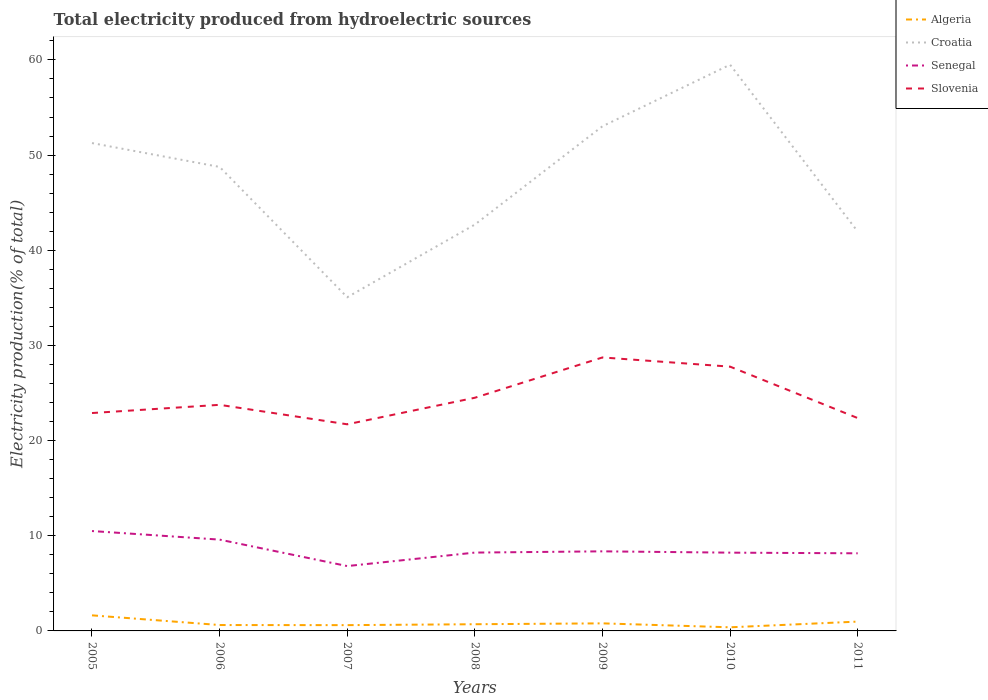Does the line corresponding to Senegal intersect with the line corresponding to Algeria?
Keep it short and to the point. No. Is the number of lines equal to the number of legend labels?
Your answer should be compact. Yes. Across all years, what is the maximum total electricity produced in Croatia?
Offer a very short reply. 35.06. What is the total total electricity produced in Algeria in the graph?
Offer a terse response. 1.02. What is the difference between the highest and the second highest total electricity produced in Slovenia?
Provide a short and direct response. 7.02. What is the difference between the highest and the lowest total electricity produced in Croatia?
Give a very brief answer. 4. Is the total electricity produced in Croatia strictly greater than the total electricity produced in Senegal over the years?
Keep it short and to the point. No. How many lines are there?
Keep it short and to the point. 4. How many years are there in the graph?
Offer a very short reply. 7. Where does the legend appear in the graph?
Provide a succinct answer. Top right. How many legend labels are there?
Make the answer very short. 4. How are the legend labels stacked?
Provide a short and direct response. Vertical. What is the title of the graph?
Give a very brief answer. Total electricity produced from hydroelectric sources. What is the label or title of the X-axis?
Your answer should be compact. Years. What is the Electricity production(% of total) of Algeria in 2005?
Provide a short and direct response. 1.64. What is the Electricity production(% of total) in Croatia in 2005?
Ensure brevity in your answer.  51.26. What is the Electricity production(% of total) in Senegal in 2005?
Give a very brief answer. 10.5. What is the Electricity production(% of total) of Slovenia in 2005?
Offer a terse response. 22.89. What is the Electricity production(% of total) in Algeria in 2006?
Your answer should be compact. 0.62. What is the Electricity production(% of total) of Croatia in 2006?
Your answer should be very brief. 48.76. What is the Electricity production(% of total) of Senegal in 2006?
Ensure brevity in your answer.  9.59. What is the Electricity production(% of total) of Slovenia in 2006?
Make the answer very short. 23.76. What is the Electricity production(% of total) in Algeria in 2007?
Your response must be concise. 0.61. What is the Electricity production(% of total) in Croatia in 2007?
Your answer should be compact. 35.06. What is the Electricity production(% of total) of Senegal in 2007?
Your answer should be compact. 6.81. What is the Electricity production(% of total) of Slovenia in 2007?
Keep it short and to the point. 21.71. What is the Electricity production(% of total) in Algeria in 2008?
Keep it short and to the point. 0.7. What is the Electricity production(% of total) of Croatia in 2008?
Your answer should be very brief. 42.7. What is the Electricity production(% of total) of Senegal in 2008?
Make the answer very short. 8.23. What is the Electricity production(% of total) in Slovenia in 2008?
Provide a short and direct response. 24.5. What is the Electricity production(% of total) of Algeria in 2009?
Ensure brevity in your answer.  0.79. What is the Electricity production(% of total) of Croatia in 2009?
Provide a short and direct response. 53.03. What is the Electricity production(% of total) of Senegal in 2009?
Give a very brief answer. 8.36. What is the Electricity production(% of total) in Slovenia in 2009?
Provide a short and direct response. 28.74. What is the Electricity production(% of total) in Algeria in 2010?
Make the answer very short. 0.38. What is the Electricity production(% of total) of Croatia in 2010?
Offer a terse response. 59.5. What is the Electricity production(% of total) in Senegal in 2010?
Offer a very short reply. 8.22. What is the Electricity production(% of total) of Slovenia in 2010?
Ensure brevity in your answer.  27.77. What is the Electricity production(% of total) of Algeria in 2011?
Provide a short and direct response. 0.98. What is the Electricity production(% of total) in Croatia in 2011?
Provide a succinct answer. 41.96. What is the Electricity production(% of total) in Senegal in 2011?
Your response must be concise. 8.16. What is the Electricity production(% of total) in Slovenia in 2011?
Provide a succinct answer. 22.37. Across all years, what is the maximum Electricity production(% of total) of Algeria?
Provide a short and direct response. 1.64. Across all years, what is the maximum Electricity production(% of total) in Croatia?
Your answer should be compact. 59.5. Across all years, what is the maximum Electricity production(% of total) in Senegal?
Give a very brief answer. 10.5. Across all years, what is the maximum Electricity production(% of total) of Slovenia?
Ensure brevity in your answer.  28.74. Across all years, what is the minimum Electricity production(% of total) in Algeria?
Make the answer very short. 0.38. Across all years, what is the minimum Electricity production(% of total) in Croatia?
Provide a short and direct response. 35.06. Across all years, what is the minimum Electricity production(% of total) of Senegal?
Keep it short and to the point. 6.81. Across all years, what is the minimum Electricity production(% of total) of Slovenia?
Ensure brevity in your answer.  21.71. What is the total Electricity production(% of total) of Algeria in the graph?
Ensure brevity in your answer.  5.72. What is the total Electricity production(% of total) in Croatia in the graph?
Give a very brief answer. 332.27. What is the total Electricity production(% of total) in Senegal in the graph?
Your answer should be very brief. 59.88. What is the total Electricity production(% of total) in Slovenia in the graph?
Your answer should be compact. 171.74. What is the difference between the Electricity production(% of total) in Algeria in 2005 and that in 2006?
Ensure brevity in your answer.  1.02. What is the difference between the Electricity production(% of total) in Croatia in 2005 and that in 2006?
Make the answer very short. 2.51. What is the difference between the Electricity production(% of total) of Senegal in 2005 and that in 2006?
Make the answer very short. 0.9. What is the difference between the Electricity production(% of total) of Slovenia in 2005 and that in 2006?
Provide a short and direct response. -0.86. What is the difference between the Electricity production(% of total) of Algeria in 2005 and that in 2007?
Give a very brief answer. 1.03. What is the difference between the Electricity production(% of total) of Croatia in 2005 and that in 2007?
Your answer should be compact. 16.2. What is the difference between the Electricity production(% of total) in Senegal in 2005 and that in 2007?
Keep it short and to the point. 3.68. What is the difference between the Electricity production(% of total) in Slovenia in 2005 and that in 2007?
Your answer should be very brief. 1.18. What is the difference between the Electricity production(% of total) in Algeria in 2005 and that in 2008?
Ensure brevity in your answer.  0.93. What is the difference between the Electricity production(% of total) of Croatia in 2005 and that in 2008?
Your answer should be compact. 8.56. What is the difference between the Electricity production(% of total) of Senegal in 2005 and that in 2008?
Your answer should be very brief. 2.26. What is the difference between the Electricity production(% of total) of Slovenia in 2005 and that in 2008?
Your answer should be compact. -1.61. What is the difference between the Electricity production(% of total) in Algeria in 2005 and that in 2009?
Provide a succinct answer. 0.84. What is the difference between the Electricity production(% of total) in Croatia in 2005 and that in 2009?
Give a very brief answer. -1.77. What is the difference between the Electricity production(% of total) of Senegal in 2005 and that in 2009?
Provide a short and direct response. 2.13. What is the difference between the Electricity production(% of total) in Slovenia in 2005 and that in 2009?
Keep it short and to the point. -5.84. What is the difference between the Electricity production(% of total) of Algeria in 2005 and that in 2010?
Make the answer very short. 1.26. What is the difference between the Electricity production(% of total) in Croatia in 2005 and that in 2010?
Your answer should be very brief. -8.23. What is the difference between the Electricity production(% of total) of Senegal in 2005 and that in 2010?
Offer a terse response. 2.27. What is the difference between the Electricity production(% of total) of Slovenia in 2005 and that in 2010?
Your answer should be compact. -4.87. What is the difference between the Electricity production(% of total) in Algeria in 2005 and that in 2011?
Offer a terse response. 0.66. What is the difference between the Electricity production(% of total) of Croatia in 2005 and that in 2011?
Offer a very short reply. 9.3. What is the difference between the Electricity production(% of total) in Senegal in 2005 and that in 2011?
Keep it short and to the point. 2.34. What is the difference between the Electricity production(% of total) in Slovenia in 2005 and that in 2011?
Provide a succinct answer. 0.53. What is the difference between the Electricity production(% of total) in Algeria in 2006 and that in 2007?
Provide a succinct answer. 0.01. What is the difference between the Electricity production(% of total) in Croatia in 2006 and that in 2007?
Ensure brevity in your answer.  13.69. What is the difference between the Electricity production(% of total) in Senegal in 2006 and that in 2007?
Offer a very short reply. 2.78. What is the difference between the Electricity production(% of total) in Slovenia in 2006 and that in 2007?
Offer a very short reply. 2.05. What is the difference between the Electricity production(% of total) of Algeria in 2006 and that in 2008?
Offer a very short reply. -0.08. What is the difference between the Electricity production(% of total) in Croatia in 2006 and that in 2008?
Offer a very short reply. 6.06. What is the difference between the Electricity production(% of total) in Senegal in 2006 and that in 2008?
Keep it short and to the point. 1.36. What is the difference between the Electricity production(% of total) in Slovenia in 2006 and that in 2008?
Your answer should be very brief. -0.74. What is the difference between the Electricity production(% of total) of Algeria in 2006 and that in 2009?
Make the answer very short. -0.18. What is the difference between the Electricity production(% of total) in Croatia in 2006 and that in 2009?
Provide a succinct answer. -4.27. What is the difference between the Electricity production(% of total) of Senegal in 2006 and that in 2009?
Your answer should be compact. 1.23. What is the difference between the Electricity production(% of total) in Slovenia in 2006 and that in 2009?
Provide a short and direct response. -4.98. What is the difference between the Electricity production(% of total) in Algeria in 2006 and that in 2010?
Your answer should be compact. 0.24. What is the difference between the Electricity production(% of total) of Croatia in 2006 and that in 2010?
Keep it short and to the point. -10.74. What is the difference between the Electricity production(% of total) in Senegal in 2006 and that in 2010?
Offer a very short reply. 1.37. What is the difference between the Electricity production(% of total) of Slovenia in 2006 and that in 2010?
Offer a terse response. -4.01. What is the difference between the Electricity production(% of total) in Algeria in 2006 and that in 2011?
Offer a very short reply. -0.36. What is the difference between the Electricity production(% of total) of Croatia in 2006 and that in 2011?
Offer a terse response. 6.79. What is the difference between the Electricity production(% of total) in Senegal in 2006 and that in 2011?
Give a very brief answer. 1.44. What is the difference between the Electricity production(% of total) in Slovenia in 2006 and that in 2011?
Your answer should be very brief. 1.39. What is the difference between the Electricity production(% of total) in Algeria in 2007 and that in 2008?
Give a very brief answer. -0.1. What is the difference between the Electricity production(% of total) in Croatia in 2007 and that in 2008?
Ensure brevity in your answer.  -7.63. What is the difference between the Electricity production(% of total) of Senegal in 2007 and that in 2008?
Your answer should be compact. -1.42. What is the difference between the Electricity production(% of total) of Slovenia in 2007 and that in 2008?
Make the answer very short. -2.79. What is the difference between the Electricity production(% of total) of Algeria in 2007 and that in 2009?
Give a very brief answer. -0.19. What is the difference between the Electricity production(% of total) in Croatia in 2007 and that in 2009?
Provide a succinct answer. -17.97. What is the difference between the Electricity production(% of total) of Senegal in 2007 and that in 2009?
Ensure brevity in your answer.  -1.55. What is the difference between the Electricity production(% of total) of Slovenia in 2007 and that in 2009?
Provide a short and direct response. -7.03. What is the difference between the Electricity production(% of total) of Algeria in 2007 and that in 2010?
Offer a very short reply. 0.23. What is the difference between the Electricity production(% of total) of Croatia in 2007 and that in 2010?
Provide a succinct answer. -24.43. What is the difference between the Electricity production(% of total) of Senegal in 2007 and that in 2010?
Your answer should be very brief. -1.41. What is the difference between the Electricity production(% of total) in Slovenia in 2007 and that in 2010?
Your answer should be very brief. -6.06. What is the difference between the Electricity production(% of total) in Algeria in 2007 and that in 2011?
Provide a short and direct response. -0.37. What is the difference between the Electricity production(% of total) in Croatia in 2007 and that in 2011?
Provide a short and direct response. -6.9. What is the difference between the Electricity production(% of total) in Senegal in 2007 and that in 2011?
Provide a succinct answer. -1.34. What is the difference between the Electricity production(% of total) in Slovenia in 2007 and that in 2011?
Offer a very short reply. -0.65. What is the difference between the Electricity production(% of total) in Algeria in 2008 and that in 2009?
Ensure brevity in your answer.  -0.09. What is the difference between the Electricity production(% of total) in Croatia in 2008 and that in 2009?
Ensure brevity in your answer.  -10.33. What is the difference between the Electricity production(% of total) of Senegal in 2008 and that in 2009?
Offer a very short reply. -0.13. What is the difference between the Electricity production(% of total) in Slovenia in 2008 and that in 2009?
Make the answer very short. -4.23. What is the difference between the Electricity production(% of total) in Algeria in 2008 and that in 2010?
Your answer should be compact. 0.32. What is the difference between the Electricity production(% of total) of Croatia in 2008 and that in 2010?
Ensure brevity in your answer.  -16.8. What is the difference between the Electricity production(% of total) in Senegal in 2008 and that in 2010?
Your response must be concise. 0.01. What is the difference between the Electricity production(% of total) of Slovenia in 2008 and that in 2010?
Your response must be concise. -3.27. What is the difference between the Electricity production(% of total) of Algeria in 2008 and that in 2011?
Make the answer very short. -0.28. What is the difference between the Electricity production(% of total) of Croatia in 2008 and that in 2011?
Provide a succinct answer. 0.73. What is the difference between the Electricity production(% of total) of Senegal in 2008 and that in 2011?
Make the answer very short. 0.08. What is the difference between the Electricity production(% of total) of Slovenia in 2008 and that in 2011?
Your answer should be compact. 2.14. What is the difference between the Electricity production(% of total) of Algeria in 2009 and that in 2010?
Your response must be concise. 0.41. What is the difference between the Electricity production(% of total) of Croatia in 2009 and that in 2010?
Offer a very short reply. -6.47. What is the difference between the Electricity production(% of total) in Senegal in 2009 and that in 2010?
Your answer should be compact. 0.14. What is the difference between the Electricity production(% of total) of Slovenia in 2009 and that in 2010?
Provide a succinct answer. 0.97. What is the difference between the Electricity production(% of total) of Algeria in 2009 and that in 2011?
Your answer should be very brief. -0.19. What is the difference between the Electricity production(% of total) of Croatia in 2009 and that in 2011?
Give a very brief answer. 11.07. What is the difference between the Electricity production(% of total) in Senegal in 2009 and that in 2011?
Provide a succinct answer. 0.21. What is the difference between the Electricity production(% of total) of Slovenia in 2009 and that in 2011?
Ensure brevity in your answer.  6.37. What is the difference between the Electricity production(% of total) in Algeria in 2010 and that in 2011?
Provide a short and direct response. -0.6. What is the difference between the Electricity production(% of total) in Croatia in 2010 and that in 2011?
Give a very brief answer. 17.53. What is the difference between the Electricity production(% of total) in Senegal in 2010 and that in 2011?
Your answer should be compact. 0.07. What is the difference between the Electricity production(% of total) of Slovenia in 2010 and that in 2011?
Ensure brevity in your answer.  5.4. What is the difference between the Electricity production(% of total) in Algeria in 2005 and the Electricity production(% of total) in Croatia in 2006?
Make the answer very short. -47.12. What is the difference between the Electricity production(% of total) in Algeria in 2005 and the Electricity production(% of total) in Senegal in 2006?
Your answer should be compact. -7.96. What is the difference between the Electricity production(% of total) in Algeria in 2005 and the Electricity production(% of total) in Slovenia in 2006?
Offer a very short reply. -22.12. What is the difference between the Electricity production(% of total) of Croatia in 2005 and the Electricity production(% of total) of Senegal in 2006?
Give a very brief answer. 41.67. What is the difference between the Electricity production(% of total) of Croatia in 2005 and the Electricity production(% of total) of Slovenia in 2006?
Offer a terse response. 27.5. What is the difference between the Electricity production(% of total) in Senegal in 2005 and the Electricity production(% of total) in Slovenia in 2006?
Give a very brief answer. -13.26. What is the difference between the Electricity production(% of total) of Algeria in 2005 and the Electricity production(% of total) of Croatia in 2007?
Offer a terse response. -33.43. What is the difference between the Electricity production(% of total) of Algeria in 2005 and the Electricity production(% of total) of Senegal in 2007?
Provide a short and direct response. -5.18. What is the difference between the Electricity production(% of total) of Algeria in 2005 and the Electricity production(% of total) of Slovenia in 2007?
Offer a very short reply. -20.07. What is the difference between the Electricity production(% of total) of Croatia in 2005 and the Electricity production(% of total) of Senegal in 2007?
Your answer should be very brief. 44.45. What is the difference between the Electricity production(% of total) in Croatia in 2005 and the Electricity production(% of total) in Slovenia in 2007?
Your answer should be compact. 29.55. What is the difference between the Electricity production(% of total) in Senegal in 2005 and the Electricity production(% of total) in Slovenia in 2007?
Offer a terse response. -11.22. What is the difference between the Electricity production(% of total) of Algeria in 2005 and the Electricity production(% of total) of Croatia in 2008?
Give a very brief answer. -41.06. What is the difference between the Electricity production(% of total) of Algeria in 2005 and the Electricity production(% of total) of Senegal in 2008?
Offer a terse response. -6.59. What is the difference between the Electricity production(% of total) in Algeria in 2005 and the Electricity production(% of total) in Slovenia in 2008?
Provide a short and direct response. -22.86. What is the difference between the Electricity production(% of total) in Croatia in 2005 and the Electricity production(% of total) in Senegal in 2008?
Keep it short and to the point. 43.03. What is the difference between the Electricity production(% of total) in Croatia in 2005 and the Electricity production(% of total) in Slovenia in 2008?
Give a very brief answer. 26.76. What is the difference between the Electricity production(% of total) of Senegal in 2005 and the Electricity production(% of total) of Slovenia in 2008?
Your answer should be compact. -14.01. What is the difference between the Electricity production(% of total) of Algeria in 2005 and the Electricity production(% of total) of Croatia in 2009?
Your response must be concise. -51.39. What is the difference between the Electricity production(% of total) of Algeria in 2005 and the Electricity production(% of total) of Senegal in 2009?
Offer a terse response. -6.73. What is the difference between the Electricity production(% of total) in Algeria in 2005 and the Electricity production(% of total) in Slovenia in 2009?
Offer a very short reply. -27.1. What is the difference between the Electricity production(% of total) of Croatia in 2005 and the Electricity production(% of total) of Senegal in 2009?
Your answer should be compact. 42.9. What is the difference between the Electricity production(% of total) of Croatia in 2005 and the Electricity production(% of total) of Slovenia in 2009?
Keep it short and to the point. 22.53. What is the difference between the Electricity production(% of total) in Senegal in 2005 and the Electricity production(% of total) in Slovenia in 2009?
Your answer should be compact. -18.24. What is the difference between the Electricity production(% of total) of Algeria in 2005 and the Electricity production(% of total) of Croatia in 2010?
Provide a short and direct response. -57.86. What is the difference between the Electricity production(% of total) of Algeria in 2005 and the Electricity production(% of total) of Senegal in 2010?
Your response must be concise. -6.59. What is the difference between the Electricity production(% of total) of Algeria in 2005 and the Electricity production(% of total) of Slovenia in 2010?
Your response must be concise. -26.13. What is the difference between the Electricity production(% of total) in Croatia in 2005 and the Electricity production(% of total) in Senegal in 2010?
Give a very brief answer. 43.04. What is the difference between the Electricity production(% of total) of Croatia in 2005 and the Electricity production(% of total) of Slovenia in 2010?
Provide a short and direct response. 23.49. What is the difference between the Electricity production(% of total) in Senegal in 2005 and the Electricity production(% of total) in Slovenia in 2010?
Ensure brevity in your answer.  -17.27. What is the difference between the Electricity production(% of total) of Algeria in 2005 and the Electricity production(% of total) of Croatia in 2011?
Your answer should be very brief. -40.33. What is the difference between the Electricity production(% of total) of Algeria in 2005 and the Electricity production(% of total) of Senegal in 2011?
Offer a terse response. -6.52. What is the difference between the Electricity production(% of total) in Algeria in 2005 and the Electricity production(% of total) in Slovenia in 2011?
Offer a terse response. -20.73. What is the difference between the Electricity production(% of total) in Croatia in 2005 and the Electricity production(% of total) in Senegal in 2011?
Your answer should be compact. 43.11. What is the difference between the Electricity production(% of total) in Croatia in 2005 and the Electricity production(% of total) in Slovenia in 2011?
Ensure brevity in your answer.  28.9. What is the difference between the Electricity production(% of total) of Senegal in 2005 and the Electricity production(% of total) of Slovenia in 2011?
Offer a terse response. -11.87. What is the difference between the Electricity production(% of total) in Algeria in 2006 and the Electricity production(% of total) in Croatia in 2007?
Offer a terse response. -34.44. What is the difference between the Electricity production(% of total) in Algeria in 2006 and the Electricity production(% of total) in Senegal in 2007?
Your answer should be very brief. -6.2. What is the difference between the Electricity production(% of total) in Algeria in 2006 and the Electricity production(% of total) in Slovenia in 2007?
Offer a very short reply. -21.09. What is the difference between the Electricity production(% of total) in Croatia in 2006 and the Electricity production(% of total) in Senegal in 2007?
Offer a very short reply. 41.94. What is the difference between the Electricity production(% of total) of Croatia in 2006 and the Electricity production(% of total) of Slovenia in 2007?
Provide a short and direct response. 27.05. What is the difference between the Electricity production(% of total) in Senegal in 2006 and the Electricity production(% of total) in Slovenia in 2007?
Provide a short and direct response. -12.12. What is the difference between the Electricity production(% of total) in Algeria in 2006 and the Electricity production(% of total) in Croatia in 2008?
Give a very brief answer. -42.08. What is the difference between the Electricity production(% of total) in Algeria in 2006 and the Electricity production(% of total) in Senegal in 2008?
Your response must be concise. -7.61. What is the difference between the Electricity production(% of total) in Algeria in 2006 and the Electricity production(% of total) in Slovenia in 2008?
Your response must be concise. -23.88. What is the difference between the Electricity production(% of total) of Croatia in 2006 and the Electricity production(% of total) of Senegal in 2008?
Keep it short and to the point. 40.53. What is the difference between the Electricity production(% of total) in Croatia in 2006 and the Electricity production(% of total) in Slovenia in 2008?
Make the answer very short. 24.26. What is the difference between the Electricity production(% of total) of Senegal in 2006 and the Electricity production(% of total) of Slovenia in 2008?
Offer a very short reply. -14.91. What is the difference between the Electricity production(% of total) in Algeria in 2006 and the Electricity production(% of total) in Croatia in 2009?
Provide a short and direct response. -52.41. What is the difference between the Electricity production(% of total) in Algeria in 2006 and the Electricity production(% of total) in Senegal in 2009?
Your answer should be very brief. -7.74. What is the difference between the Electricity production(% of total) of Algeria in 2006 and the Electricity production(% of total) of Slovenia in 2009?
Give a very brief answer. -28.12. What is the difference between the Electricity production(% of total) of Croatia in 2006 and the Electricity production(% of total) of Senegal in 2009?
Make the answer very short. 40.39. What is the difference between the Electricity production(% of total) of Croatia in 2006 and the Electricity production(% of total) of Slovenia in 2009?
Provide a succinct answer. 20.02. What is the difference between the Electricity production(% of total) in Senegal in 2006 and the Electricity production(% of total) in Slovenia in 2009?
Offer a very short reply. -19.14. What is the difference between the Electricity production(% of total) of Algeria in 2006 and the Electricity production(% of total) of Croatia in 2010?
Your answer should be very brief. -58.88. What is the difference between the Electricity production(% of total) in Algeria in 2006 and the Electricity production(% of total) in Senegal in 2010?
Ensure brevity in your answer.  -7.61. What is the difference between the Electricity production(% of total) of Algeria in 2006 and the Electricity production(% of total) of Slovenia in 2010?
Offer a very short reply. -27.15. What is the difference between the Electricity production(% of total) of Croatia in 2006 and the Electricity production(% of total) of Senegal in 2010?
Your answer should be very brief. 40.53. What is the difference between the Electricity production(% of total) of Croatia in 2006 and the Electricity production(% of total) of Slovenia in 2010?
Ensure brevity in your answer.  20.99. What is the difference between the Electricity production(% of total) in Senegal in 2006 and the Electricity production(% of total) in Slovenia in 2010?
Make the answer very short. -18.18. What is the difference between the Electricity production(% of total) of Algeria in 2006 and the Electricity production(% of total) of Croatia in 2011?
Your answer should be compact. -41.35. What is the difference between the Electricity production(% of total) of Algeria in 2006 and the Electricity production(% of total) of Senegal in 2011?
Make the answer very short. -7.54. What is the difference between the Electricity production(% of total) in Algeria in 2006 and the Electricity production(% of total) in Slovenia in 2011?
Keep it short and to the point. -21.75. What is the difference between the Electricity production(% of total) of Croatia in 2006 and the Electricity production(% of total) of Senegal in 2011?
Offer a terse response. 40.6. What is the difference between the Electricity production(% of total) of Croatia in 2006 and the Electricity production(% of total) of Slovenia in 2011?
Your answer should be very brief. 26.39. What is the difference between the Electricity production(% of total) of Senegal in 2006 and the Electricity production(% of total) of Slovenia in 2011?
Your response must be concise. -12.77. What is the difference between the Electricity production(% of total) in Algeria in 2007 and the Electricity production(% of total) in Croatia in 2008?
Provide a short and direct response. -42.09. What is the difference between the Electricity production(% of total) of Algeria in 2007 and the Electricity production(% of total) of Senegal in 2008?
Provide a short and direct response. -7.62. What is the difference between the Electricity production(% of total) in Algeria in 2007 and the Electricity production(% of total) in Slovenia in 2008?
Your answer should be very brief. -23.89. What is the difference between the Electricity production(% of total) in Croatia in 2007 and the Electricity production(% of total) in Senegal in 2008?
Offer a very short reply. 26.83. What is the difference between the Electricity production(% of total) of Croatia in 2007 and the Electricity production(% of total) of Slovenia in 2008?
Your answer should be compact. 10.56. What is the difference between the Electricity production(% of total) in Senegal in 2007 and the Electricity production(% of total) in Slovenia in 2008?
Make the answer very short. -17.69. What is the difference between the Electricity production(% of total) of Algeria in 2007 and the Electricity production(% of total) of Croatia in 2009?
Offer a very short reply. -52.42. What is the difference between the Electricity production(% of total) in Algeria in 2007 and the Electricity production(% of total) in Senegal in 2009?
Give a very brief answer. -7.75. What is the difference between the Electricity production(% of total) in Algeria in 2007 and the Electricity production(% of total) in Slovenia in 2009?
Ensure brevity in your answer.  -28.13. What is the difference between the Electricity production(% of total) of Croatia in 2007 and the Electricity production(% of total) of Senegal in 2009?
Keep it short and to the point. 26.7. What is the difference between the Electricity production(% of total) of Croatia in 2007 and the Electricity production(% of total) of Slovenia in 2009?
Provide a short and direct response. 6.33. What is the difference between the Electricity production(% of total) in Senegal in 2007 and the Electricity production(% of total) in Slovenia in 2009?
Offer a terse response. -21.92. What is the difference between the Electricity production(% of total) of Algeria in 2007 and the Electricity production(% of total) of Croatia in 2010?
Give a very brief answer. -58.89. What is the difference between the Electricity production(% of total) of Algeria in 2007 and the Electricity production(% of total) of Senegal in 2010?
Provide a succinct answer. -7.62. What is the difference between the Electricity production(% of total) in Algeria in 2007 and the Electricity production(% of total) in Slovenia in 2010?
Make the answer very short. -27.16. What is the difference between the Electricity production(% of total) of Croatia in 2007 and the Electricity production(% of total) of Senegal in 2010?
Your answer should be compact. 26.84. What is the difference between the Electricity production(% of total) of Croatia in 2007 and the Electricity production(% of total) of Slovenia in 2010?
Give a very brief answer. 7.29. What is the difference between the Electricity production(% of total) of Senegal in 2007 and the Electricity production(% of total) of Slovenia in 2010?
Ensure brevity in your answer.  -20.95. What is the difference between the Electricity production(% of total) in Algeria in 2007 and the Electricity production(% of total) in Croatia in 2011?
Ensure brevity in your answer.  -41.36. What is the difference between the Electricity production(% of total) of Algeria in 2007 and the Electricity production(% of total) of Senegal in 2011?
Make the answer very short. -7.55. What is the difference between the Electricity production(% of total) of Algeria in 2007 and the Electricity production(% of total) of Slovenia in 2011?
Your answer should be very brief. -21.76. What is the difference between the Electricity production(% of total) in Croatia in 2007 and the Electricity production(% of total) in Senegal in 2011?
Give a very brief answer. 26.91. What is the difference between the Electricity production(% of total) of Croatia in 2007 and the Electricity production(% of total) of Slovenia in 2011?
Keep it short and to the point. 12.7. What is the difference between the Electricity production(% of total) of Senegal in 2007 and the Electricity production(% of total) of Slovenia in 2011?
Provide a short and direct response. -15.55. What is the difference between the Electricity production(% of total) of Algeria in 2008 and the Electricity production(% of total) of Croatia in 2009?
Offer a terse response. -52.33. What is the difference between the Electricity production(% of total) of Algeria in 2008 and the Electricity production(% of total) of Senegal in 2009?
Offer a very short reply. -7.66. What is the difference between the Electricity production(% of total) in Algeria in 2008 and the Electricity production(% of total) in Slovenia in 2009?
Make the answer very short. -28.03. What is the difference between the Electricity production(% of total) in Croatia in 2008 and the Electricity production(% of total) in Senegal in 2009?
Your response must be concise. 34.34. What is the difference between the Electricity production(% of total) in Croatia in 2008 and the Electricity production(% of total) in Slovenia in 2009?
Offer a terse response. 13.96. What is the difference between the Electricity production(% of total) of Senegal in 2008 and the Electricity production(% of total) of Slovenia in 2009?
Ensure brevity in your answer.  -20.5. What is the difference between the Electricity production(% of total) of Algeria in 2008 and the Electricity production(% of total) of Croatia in 2010?
Your answer should be compact. -58.79. What is the difference between the Electricity production(% of total) in Algeria in 2008 and the Electricity production(% of total) in Senegal in 2010?
Offer a very short reply. -7.52. What is the difference between the Electricity production(% of total) in Algeria in 2008 and the Electricity production(% of total) in Slovenia in 2010?
Offer a terse response. -27.07. What is the difference between the Electricity production(% of total) of Croatia in 2008 and the Electricity production(% of total) of Senegal in 2010?
Offer a very short reply. 34.47. What is the difference between the Electricity production(% of total) in Croatia in 2008 and the Electricity production(% of total) in Slovenia in 2010?
Provide a short and direct response. 14.93. What is the difference between the Electricity production(% of total) of Senegal in 2008 and the Electricity production(% of total) of Slovenia in 2010?
Your answer should be very brief. -19.54. What is the difference between the Electricity production(% of total) of Algeria in 2008 and the Electricity production(% of total) of Croatia in 2011?
Provide a short and direct response. -41.26. What is the difference between the Electricity production(% of total) of Algeria in 2008 and the Electricity production(% of total) of Senegal in 2011?
Provide a succinct answer. -7.45. What is the difference between the Electricity production(% of total) in Algeria in 2008 and the Electricity production(% of total) in Slovenia in 2011?
Provide a short and direct response. -21.66. What is the difference between the Electricity production(% of total) in Croatia in 2008 and the Electricity production(% of total) in Senegal in 2011?
Offer a very short reply. 34.54. What is the difference between the Electricity production(% of total) of Croatia in 2008 and the Electricity production(% of total) of Slovenia in 2011?
Offer a very short reply. 20.33. What is the difference between the Electricity production(% of total) of Senegal in 2008 and the Electricity production(% of total) of Slovenia in 2011?
Your answer should be very brief. -14.13. What is the difference between the Electricity production(% of total) of Algeria in 2009 and the Electricity production(% of total) of Croatia in 2010?
Make the answer very short. -58.7. What is the difference between the Electricity production(% of total) of Algeria in 2009 and the Electricity production(% of total) of Senegal in 2010?
Ensure brevity in your answer.  -7.43. What is the difference between the Electricity production(% of total) in Algeria in 2009 and the Electricity production(% of total) in Slovenia in 2010?
Your answer should be compact. -26.97. What is the difference between the Electricity production(% of total) in Croatia in 2009 and the Electricity production(% of total) in Senegal in 2010?
Provide a short and direct response. 44.8. What is the difference between the Electricity production(% of total) of Croatia in 2009 and the Electricity production(% of total) of Slovenia in 2010?
Offer a terse response. 25.26. What is the difference between the Electricity production(% of total) in Senegal in 2009 and the Electricity production(% of total) in Slovenia in 2010?
Keep it short and to the point. -19.41. What is the difference between the Electricity production(% of total) in Algeria in 2009 and the Electricity production(% of total) in Croatia in 2011?
Offer a very short reply. -41.17. What is the difference between the Electricity production(% of total) in Algeria in 2009 and the Electricity production(% of total) in Senegal in 2011?
Provide a short and direct response. -7.36. What is the difference between the Electricity production(% of total) in Algeria in 2009 and the Electricity production(% of total) in Slovenia in 2011?
Make the answer very short. -21.57. What is the difference between the Electricity production(% of total) of Croatia in 2009 and the Electricity production(% of total) of Senegal in 2011?
Provide a succinct answer. 44.87. What is the difference between the Electricity production(% of total) in Croatia in 2009 and the Electricity production(% of total) in Slovenia in 2011?
Keep it short and to the point. 30.66. What is the difference between the Electricity production(% of total) in Senegal in 2009 and the Electricity production(% of total) in Slovenia in 2011?
Offer a very short reply. -14. What is the difference between the Electricity production(% of total) in Algeria in 2010 and the Electricity production(% of total) in Croatia in 2011?
Your answer should be compact. -41.58. What is the difference between the Electricity production(% of total) in Algeria in 2010 and the Electricity production(% of total) in Senegal in 2011?
Keep it short and to the point. -7.78. What is the difference between the Electricity production(% of total) in Algeria in 2010 and the Electricity production(% of total) in Slovenia in 2011?
Offer a very short reply. -21.98. What is the difference between the Electricity production(% of total) of Croatia in 2010 and the Electricity production(% of total) of Senegal in 2011?
Offer a very short reply. 51.34. What is the difference between the Electricity production(% of total) of Croatia in 2010 and the Electricity production(% of total) of Slovenia in 2011?
Keep it short and to the point. 37.13. What is the difference between the Electricity production(% of total) of Senegal in 2010 and the Electricity production(% of total) of Slovenia in 2011?
Offer a very short reply. -14.14. What is the average Electricity production(% of total) of Algeria per year?
Give a very brief answer. 0.82. What is the average Electricity production(% of total) in Croatia per year?
Keep it short and to the point. 47.47. What is the average Electricity production(% of total) in Senegal per year?
Make the answer very short. 8.55. What is the average Electricity production(% of total) in Slovenia per year?
Make the answer very short. 24.53. In the year 2005, what is the difference between the Electricity production(% of total) in Algeria and Electricity production(% of total) in Croatia?
Keep it short and to the point. -49.63. In the year 2005, what is the difference between the Electricity production(% of total) in Algeria and Electricity production(% of total) in Senegal?
Provide a short and direct response. -8.86. In the year 2005, what is the difference between the Electricity production(% of total) of Algeria and Electricity production(% of total) of Slovenia?
Your response must be concise. -21.26. In the year 2005, what is the difference between the Electricity production(% of total) of Croatia and Electricity production(% of total) of Senegal?
Keep it short and to the point. 40.77. In the year 2005, what is the difference between the Electricity production(% of total) of Croatia and Electricity production(% of total) of Slovenia?
Your answer should be very brief. 28.37. In the year 2005, what is the difference between the Electricity production(% of total) in Senegal and Electricity production(% of total) in Slovenia?
Your response must be concise. -12.4. In the year 2006, what is the difference between the Electricity production(% of total) of Algeria and Electricity production(% of total) of Croatia?
Your answer should be compact. -48.14. In the year 2006, what is the difference between the Electricity production(% of total) of Algeria and Electricity production(% of total) of Senegal?
Keep it short and to the point. -8.98. In the year 2006, what is the difference between the Electricity production(% of total) of Algeria and Electricity production(% of total) of Slovenia?
Provide a succinct answer. -23.14. In the year 2006, what is the difference between the Electricity production(% of total) in Croatia and Electricity production(% of total) in Senegal?
Your answer should be compact. 39.16. In the year 2006, what is the difference between the Electricity production(% of total) in Croatia and Electricity production(% of total) in Slovenia?
Provide a succinct answer. 25. In the year 2006, what is the difference between the Electricity production(% of total) of Senegal and Electricity production(% of total) of Slovenia?
Offer a very short reply. -14.16. In the year 2007, what is the difference between the Electricity production(% of total) of Algeria and Electricity production(% of total) of Croatia?
Give a very brief answer. -34.46. In the year 2007, what is the difference between the Electricity production(% of total) of Algeria and Electricity production(% of total) of Senegal?
Your answer should be compact. -6.21. In the year 2007, what is the difference between the Electricity production(% of total) of Algeria and Electricity production(% of total) of Slovenia?
Your answer should be very brief. -21.1. In the year 2007, what is the difference between the Electricity production(% of total) of Croatia and Electricity production(% of total) of Senegal?
Offer a very short reply. 28.25. In the year 2007, what is the difference between the Electricity production(% of total) in Croatia and Electricity production(% of total) in Slovenia?
Ensure brevity in your answer.  13.35. In the year 2007, what is the difference between the Electricity production(% of total) in Senegal and Electricity production(% of total) in Slovenia?
Your answer should be compact. -14.9. In the year 2008, what is the difference between the Electricity production(% of total) of Algeria and Electricity production(% of total) of Croatia?
Offer a terse response. -41.99. In the year 2008, what is the difference between the Electricity production(% of total) of Algeria and Electricity production(% of total) of Senegal?
Provide a succinct answer. -7.53. In the year 2008, what is the difference between the Electricity production(% of total) of Algeria and Electricity production(% of total) of Slovenia?
Your response must be concise. -23.8. In the year 2008, what is the difference between the Electricity production(% of total) in Croatia and Electricity production(% of total) in Senegal?
Provide a short and direct response. 34.47. In the year 2008, what is the difference between the Electricity production(% of total) of Croatia and Electricity production(% of total) of Slovenia?
Give a very brief answer. 18.2. In the year 2008, what is the difference between the Electricity production(% of total) of Senegal and Electricity production(% of total) of Slovenia?
Your response must be concise. -16.27. In the year 2009, what is the difference between the Electricity production(% of total) of Algeria and Electricity production(% of total) of Croatia?
Make the answer very short. -52.23. In the year 2009, what is the difference between the Electricity production(% of total) of Algeria and Electricity production(% of total) of Senegal?
Offer a very short reply. -7.57. In the year 2009, what is the difference between the Electricity production(% of total) of Algeria and Electricity production(% of total) of Slovenia?
Offer a terse response. -27.94. In the year 2009, what is the difference between the Electricity production(% of total) in Croatia and Electricity production(% of total) in Senegal?
Offer a very short reply. 44.67. In the year 2009, what is the difference between the Electricity production(% of total) of Croatia and Electricity production(% of total) of Slovenia?
Keep it short and to the point. 24.29. In the year 2009, what is the difference between the Electricity production(% of total) of Senegal and Electricity production(% of total) of Slovenia?
Provide a succinct answer. -20.37. In the year 2010, what is the difference between the Electricity production(% of total) in Algeria and Electricity production(% of total) in Croatia?
Your answer should be compact. -59.12. In the year 2010, what is the difference between the Electricity production(% of total) in Algeria and Electricity production(% of total) in Senegal?
Keep it short and to the point. -7.84. In the year 2010, what is the difference between the Electricity production(% of total) in Algeria and Electricity production(% of total) in Slovenia?
Your answer should be very brief. -27.39. In the year 2010, what is the difference between the Electricity production(% of total) in Croatia and Electricity production(% of total) in Senegal?
Provide a succinct answer. 51.27. In the year 2010, what is the difference between the Electricity production(% of total) of Croatia and Electricity production(% of total) of Slovenia?
Make the answer very short. 31.73. In the year 2010, what is the difference between the Electricity production(% of total) in Senegal and Electricity production(% of total) in Slovenia?
Your answer should be compact. -19.54. In the year 2011, what is the difference between the Electricity production(% of total) of Algeria and Electricity production(% of total) of Croatia?
Your answer should be compact. -40.98. In the year 2011, what is the difference between the Electricity production(% of total) of Algeria and Electricity production(% of total) of Senegal?
Provide a short and direct response. -7.18. In the year 2011, what is the difference between the Electricity production(% of total) in Algeria and Electricity production(% of total) in Slovenia?
Offer a very short reply. -21.39. In the year 2011, what is the difference between the Electricity production(% of total) in Croatia and Electricity production(% of total) in Senegal?
Your response must be concise. 33.81. In the year 2011, what is the difference between the Electricity production(% of total) of Croatia and Electricity production(% of total) of Slovenia?
Provide a short and direct response. 19.6. In the year 2011, what is the difference between the Electricity production(% of total) of Senegal and Electricity production(% of total) of Slovenia?
Provide a succinct answer. -14.21. What is the ratio of the Electricity production(% of total) of Algeria in 2005 to that in 2006?
Give a very brief answer. 2.64. What is the ratio of the Electricity production(% of total) of Croatia in 2005 to that in 2006?
Your response must be concise. 1.05. What is the ratio of the Electricity production(% of total) in Senegal in 2005 to that in 2006?
Give a very brief answer. 1.09. What is the ratio of the Electricity production(% of total) in Slovenia in 2005 to that in 2006?
Keep it short and to the point. 0.96. What is the ratio of the Electricity production(% of total) in Algeria in 2005 to that in 2007?
Keep it short and to the point. 2.69. What is the ratio of the Electricity production(% of total) of Croatia in 2005 to that in 2007?
Your answer should be compact. 1.46. What is the ratio of the Electricity production(% of total) in Senegal in 2005 to that in 2007?
Offer a terse response. 1.54. What is the ratio of the Electricity production(% of total) in Slovenia in 2005 to that in 2007?
Your answer should be compact. 1.05. What is the ratio of the Electricity production(% of total) of Algeria in 2005 to that in 2008?
Your response must be concise. 2.33. What is the ratio of the Electricity production(% of total) in Croatia in 2005 to that in 2008?
Keep it short and to the point. 1.2. What is the ratio of the Electricity production(% of total) in Senegal in 2005 to that in 2008?
Ensure brevity in your answer.  1.27. What is the ratio of the Electricity production(% of total) in Slovenia in 2005 to that in 2008?
Provide a short and direct response. 0.93. What is the ratio of the Electricity production(% of total) in Algeria in 2005 to that in 2009?
Provide a short and direct response. 2.06. What is the ratio of the Electricity production(% of total) of Croatia in 2005 to that in 2009?
Your response must be concise. 0.97. What is the ratio of the Electricity production(% of total) of Senegal in 2005 to that in 2009?
Ensure brevity in your answer.  1.25. What is the ratio of the Electricity production(% of total) of Slovenia in 2005 to that in 2009?
Your answer should be compact. 0.8. What is the ratio of the Electricity production(% of total) in Algeria in 2005 to that in 2010?
Your response must be concise. 4.3. What is the ratio of the Electricity production(% of total) in Croatia in 2005 to that in 2010?
Your response must be concise. 0.86. What is the ratio of the Electricity production(% of total) of Senegal in 2005 to that in 2010?
Your answer should be very brief. 1.28. What is the ratio of the Electricity production(% of total) in Slovenia in 2005 to that in 2010?
Your answer should be compact. 0.82. What is the ratio of the Electricity production(% of total) in Algeria in 2005 to that in 2011?
Offer a terse response. 1.67. What is the ratio of the Electricity production(% of total) of Croatia in 2005 to that in 2011?
Provide a short and direct response. 1.22. What is the ratio of the Electricity production(% of total) in Senegal in 2005 to that in 2011?
Provide a short and direct response. 1.29. What is the ratio of the Electricity production(% of total) in Slovenia in 2005 to that in 2011?
Ensure brevity in your answer.  1.02. What is the ratio of the Electricity production(% of total) of Algeria in 2006 to that in 2007?
Give a very brief answer. 1.02. What is the ratio of the Electricity production(% of total) of Croatia in 2006 to that in 2007?
Offer a very short reply. 1.39. What is the ratio of the Electricity production(% of total) of Senegal in 2006 to that in 2007?
Your answer should be compact. 1.41. What is the ratio of the Electricity production(% of total) in Slovenia in 2006 to that in 2007?
Your answer should be very brief. 1.09. What is the ratio of the Electricity production(% of total) in Algeria in 2006 to that in 2008?
Provide a succinct answer. 0.88. What is the ratio of the Electricity production(% of total) in Croatia in 2006 to that in 2008?
Provide a short and direct response. 1.14. What is the ratio of the Electricity production(% of total) of Senegal in 2006 to that in 2008?
Your answer should be compact. 1.17. What is the ratio of the Electricity production(% of total) in Slovenia in 2006 to that in 2008?
Provide a succinct answer. 0.97. What is the ratio of the Electricity production(% of total) in Algeria in 2006 to that in 2009?
Your response must be concise. 0.78. What is the ratio of the Electricity production(% of total) in Croatia in 2006 to that in 2009?
Your answer should be compact. 0.92. What is the ratio of the Electricity production(% of total) in Senegal in 2006 to that in 2009?
Provide a short and direct response. 1.15. What is the ratio of the Electricity production(% of total) in Slovenia in 2006 to that in 2009?
Keep it short and to the point. 0.83. What is the ratio of the Electricity production(% of total) of Algeria in 2006 to that in 2010?
Your answer should be compact. 1.63. What is the ratio of the Electricity production(% of total) of Croatia in 2006 to that in 2010?
Provide a short and direct response. 0.82. What is the ratio of the Electricity production(% of total) of Senegal in 2006 to that in 2010?
Your answer should be compact. 1.17. What is the ratio of the Electricity production(% of total) in Slovenia in 2006 to that in 2010?
Provide a short and direct response. 0.86. What is the ratio of the Electricity production(% of total) of Algeria in 2006 to that in 2011?
Keep it short and to the point. 0.63. What is the ratio of the Electricity production(% of total) of Croatia in 2006 to that in 2011?
Provide a short and direct response. 1.16. What is the ratio of the Electricity production(% of total) of Senegal in 2006 to that in 2011?
Offer a terse response. 1.18. What is the ratio of the Electricity production(% of total) of Slovenia in 2006 to that in 2011?
Make the answer very short. 1.06. What is the ratio of the Electricity production(% of total) in Algeria in 2007 to that in 2008?
Offer a terse response. 0.86. What is the ratio of the Electricity production(% of total) of Croatia in 2007 to that in 2008?
Your response must be concise. 0.82. What is the ratio of the Electricity production(% of total) of Senegal in 2007 to that in 2008?
Offer a terse response. 0.83. What is the ratio of the Electricity production(% of total) of Slovenia in 2007 to that in 2008?
Give a very brief answer. 0.89. What is the ratio of the Electricity production(% of total) of Algeria in 2007 to that in 2009?
Your response must be concise. 0.76. What is the ratio of the Electricity production(% of total) in Croatia in 2007 to that in 2009?
Ensure brevity in your answer.  0.66. What is the ratio of the Electricity production(% of total) of Senegal in 2007 to that in 2009?
Make the answer very short. 0.81. What is the ratio of the Electricity production(% of total) in Slovenia in 2007 to that in 2009?
Your answer should be compact. 0.76. What is the ratio of the Electricity production(% of total) of Algeria in 2007 to that in 2010?
Provide a short and direct response. 1.6. What is the ratio of the Electricity production(% of total) of Croatia in 2007 to that in 2010?
Offer a terse response. 0.59. What is the ratio of the Electricity production(% of total) of Senegal in 2007 to that in 2010?
Your answer should be very brief. 0.83. What is the ratio of the Electricity production(% of total) in Slovenia in 2007 to that in 2010?
Keep it short and to the point. 0.78. What is the ratio of the Electricity production(% of total) in Algeria in 2007 to that in 2011?
Your response must be concise. 0.62. What is the ratio of the Electricity production(% of total) of Croatia in 2007 to that in 2011?
Offer a very short reply. 0.84. What is the ratio of the Electricity production(% of total) of Senegal in 2007 to that in 2011?
Ensure brevity in your answer.  0.84. What is the ratio of the Electricity production(% of total) of Slovenia in 2007 to that in 2011?
Make the answer very short. 0.97. What is the ratio of the Electricity production(% of total) in Algeria in 2008 to that in 2009?
Offer a terse response. 0.89. What is the ratio of the Electricity production(% of total) of Croatia in 2008 to that in 2009?
Keep it short and to the point. 0.81. What is the ratio of the Electricity production(% of total) of Senegal in 2008 to that in 2009?
Keep it short and to the point. 0.98. What is the ratio of the Electricity production(% of total) in Slovenia in 2008 to that in 2009?
Provide a succinct answer. 0.85. What is the ratio of the Electricity production(% of total) in Algeria in 2008 to that in 2010?
Make the answer very short. 1.85. What is the ratio of the Electricity production(% of total) of Croatia in 2008 to that in 2010?
Offer a very short reply. 0.72. What is the ratio of the Electricity production(% of total) in Senegal in 2008 to that in 2010?
Offer a terse response. 1. What is the ratio of the Electricity production(% of total) in Slovenia in 2008 to that in 2010?
Make the answer very short. 0.88. What is the ratio of the Electricity production(% of total) in Algeria in 2008 to that in 2011?
Offer a terse response. 0.72. What is the ratio of the Electricity production(% of total) of Croatia in 2008 to that in 2011?
Your answer should be very brief. 1.02. What is the ratio of the Electricity production(% of total) in Senegal in 2008 to that in 2011?
Provide a short and direct response. 1.01. What is the ratio of the Electricity production(% of total) in Slovenia in 2008 to that in 2011?
Ensure brevity in your answer.  1.1. What is the ratio of the Electricity production(% of total) of Algeria in 2009 to that in 2010?
Provide a short and direct response. 2.09. What is the ratio of the Electricity production(% of total) of Croatia in 2009 to that in 2010?
Give a very brief answer. 0.89. What is the ratio of the Electricity production(% of total) in Senegal in 2009 to that in 2010?
Offer a terse response. 1.02. What is the ratio of the Electricity production(% of total) in Slovenia in 2009 to that in 2010?
Offer a terse response. 1.03. What is the ratio of the Electricity production(% of total) of Algeria in 2009 to that in 2011?
Your answer should be compact. 0.81. What is the ratio of the Electricity production(% of total) of Croatia in 2009 to that in 2011?
Keep it short and to the point. 1.26. What is the ratio of the Electricity production(% of total) in Senegal in 2009 to that in 2011?
Offer a very short reply. 1.03. What is the ratio of the Electricity production(% of total) in Slovenia in 2009 to that in 2011?
Your answer should be very brief. 1.28. What is the ratio of the Electricity production(% of total) of Algeria in 2010 to that in 2011?
Make the answer very short. 0.39. What is the ratio of the Electricity production(% of total) of Croatia in 2010 to that in 2011?
Offer a very short reply. 1.42. What is the ratio of the Electricity production(% of total) in Senegal in 2010 to that in 2011?
Provide a short and direct response. 1.01. What is the ratio of the Electricity production(% of total) in Slovenia in 2010 to that in 2011?
Offer a terse response. 1.24. What is the difference between the highest and the second highest Electricity production(% of total) in Algeria?
Provide a short and direct response. 0.66. What is the difference between the highest and the second highest Electricity production(% of total) of Croatia?
Your response must be concise. 6.47. What is the difference between the highest and the second highest Electricity production(% of total) of Senegal?
Your response must be concise. 0.9. What is the difference between the highest and the second highest Electricity production(% of total) of Slovenia?
Offer a terse response. 0.97. What is the difference between the highest and the lowest Electricity production(% of total) in Algeria?
Your answer should be compact. 1.26. What is the difference between the highest and the lowest Electricity production(% of total) of Croatia?
Give a very brief answer. 24.43. What is the difference between the highest and the lowest Electricity production(% of total) of Senegal?
Your answer should be compact. 3.68. What is the difference between the highest and the lowest Electricity production(% of total) in Slovenia?
Ensure brevity in your answer.  7.03. 